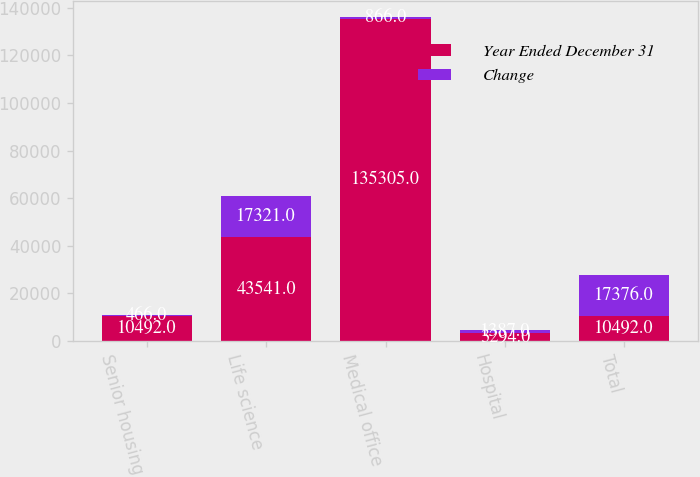<chart> <loc_0><loc_0><loc_500><loc_500><stacked_bar_chart><ecel><fcel>Senior housing<fcel>Life science<fcel>Medical office<fcel>Hospital<fcel>Total<nl><fcel>Year Ended December 31<fcel>10492<fcel>43541<fcel>135305<fcel>3294<fcel>10492<nl><fcel>Change<fcel>466<fcel>17321<fcel>866<fcel>1387<fcel>17376<nl></chart> 